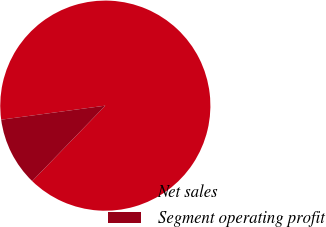<chart> <loc_0><loc_0><loc_500><loc_500><pie_chart><fcel>Net sales<fcel>Segment operating profit<nl><fcel>89.38%<fcel>10.62%<nl></chart> 